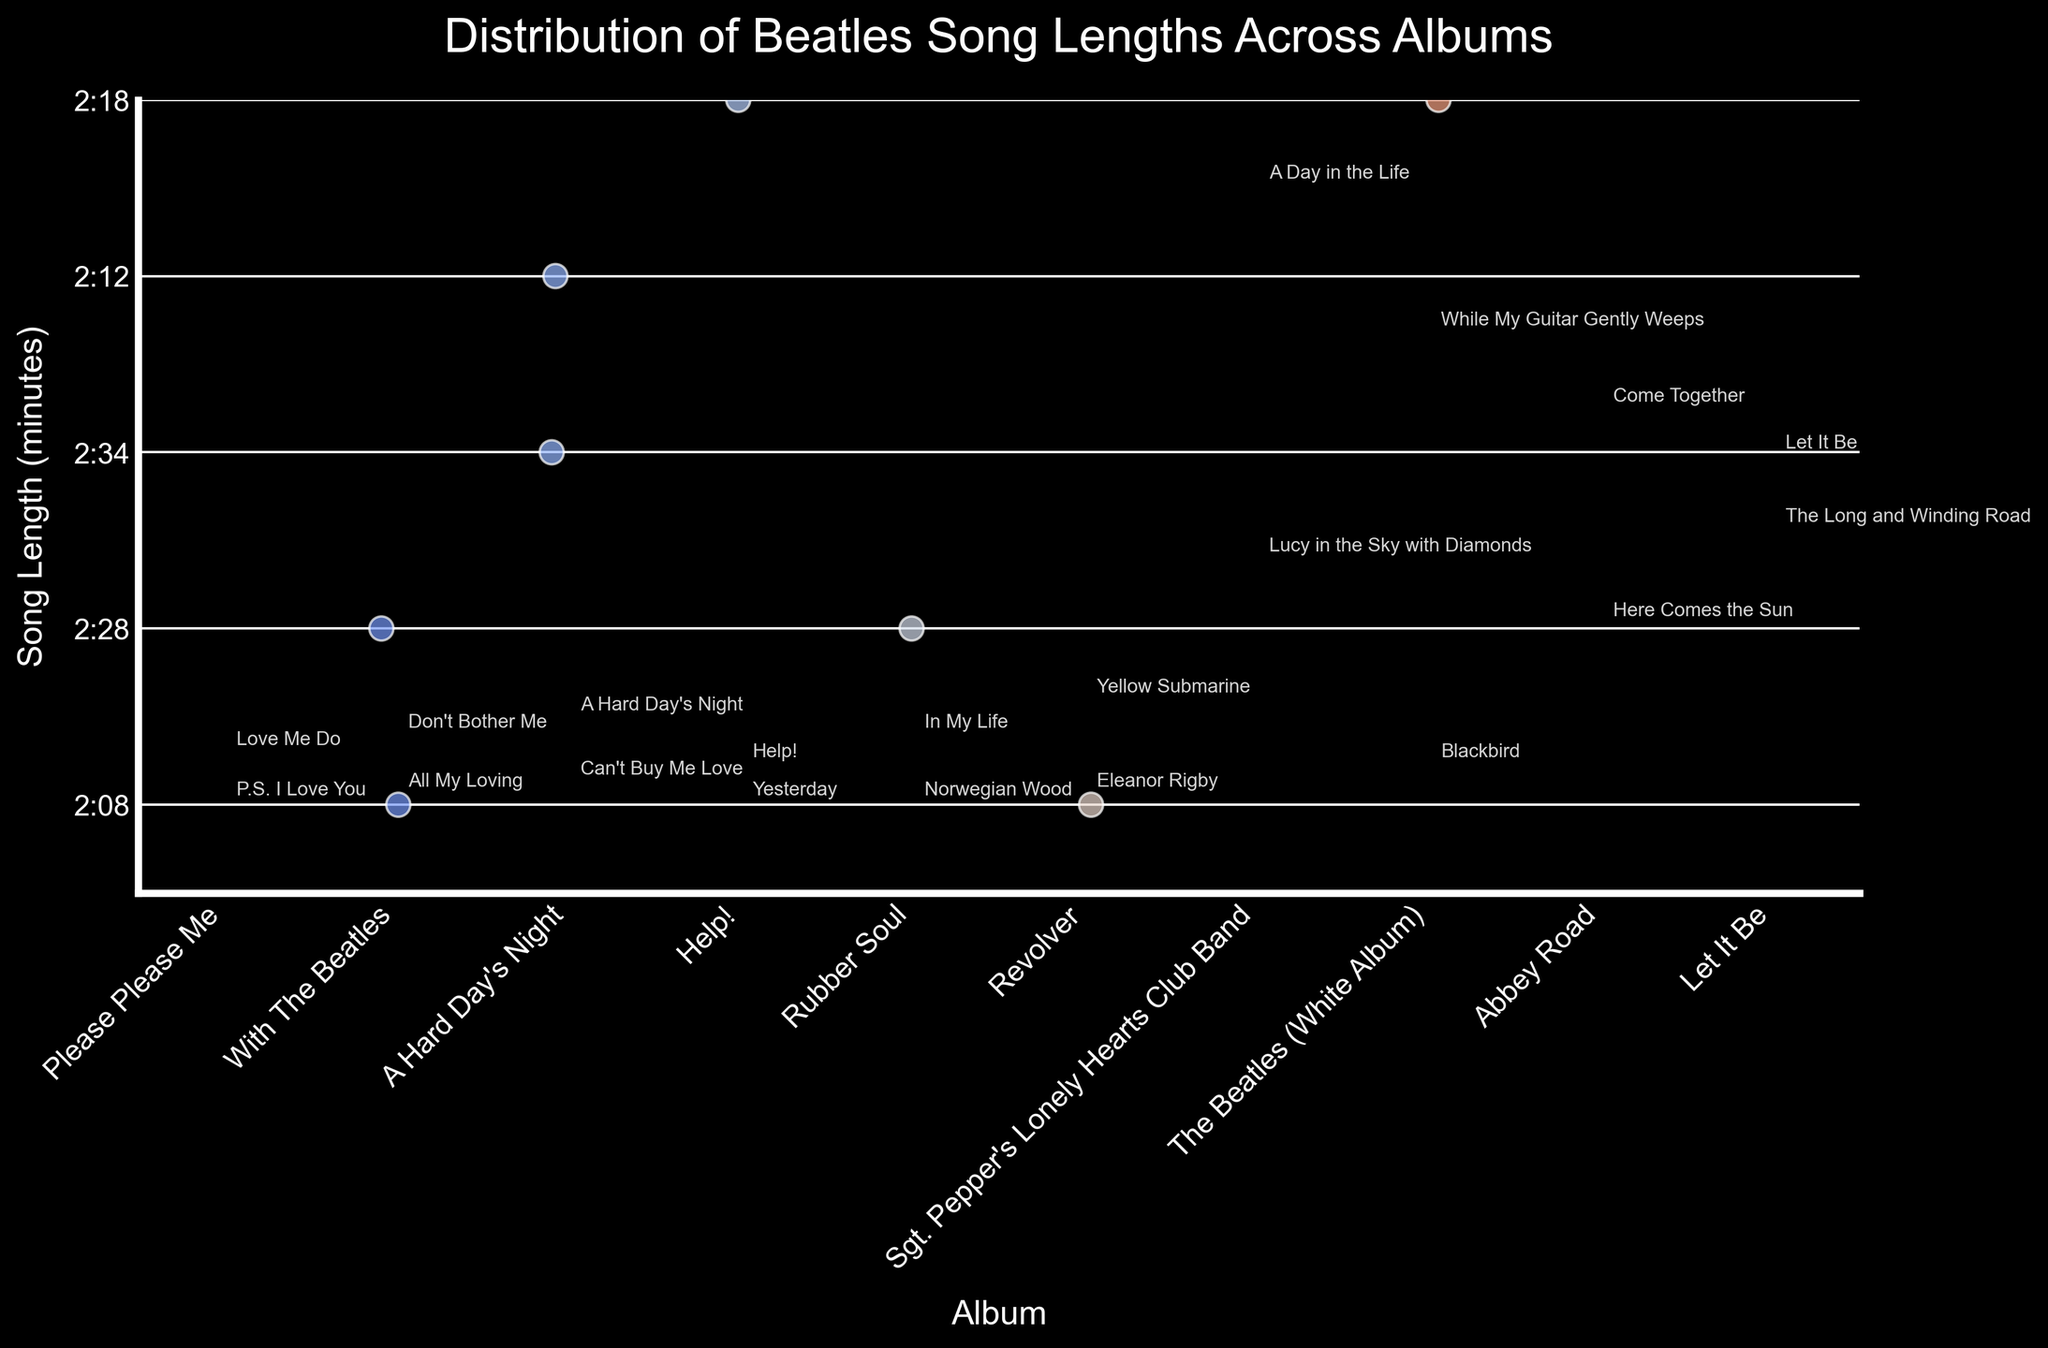what is the title of the figure? The title of the figure is usually found at the top, central part of the plot. It is often larger in font size compared to other text in the plot.
Answer: Distribution of Beatles Song Lengths Across Albums which album has the longest average song length? To find the album with the longest average song length, identify all song lengths per album and calculate the average for each. The album with the highest average is the answer.
Answer: The Beatles (White Album) what is the shortest song length on the album "Help!"? Locate the songs under the "Help!" album and check the length values of these songs. The shortest one will be the answer.
Answer: 2:05 which album contains the song with the longest length? Identify the album associated with the song of the longest length by evaluating all song lengths in the plot.
Answer: Sgt. Pepper's Lonely Hearts Club Band how many songs from the "Rubber Soul" album are included in the plot? Identify and count all the songs listed under the "Rubber Soul" album in the plot.
Answer: 2 which two albums have the shortest and longest songs respectively? Find the lengths of the shortest and longest songs in the plot and determine which albums they belong to.
Answer: Shortest: Please Please Me, Longest: Sgt. Pepper's Lonely Hearts Club Band compare the average song lengths between "A Hard Day's Night" and "Abbey Road" Calculate the average song length for each of the albums "A Hard Day's Night" and "Abbey Road", then compare the two averages.
Answer: Abbey Road has longer average song lengths than A Hard Day's Night do any albums have a song length exceeding 5 minutes? Analyze all song lengths and identify if any songs are greater than 5 minutes in duration. Check the album they belong to.
Answer: Yes, Sgt. Pepper's Lonely Hearts Club Band which album has the greatest range in song lengths? For each album, find the difference between the maximum and minimum song lengths, and identify the album with the highest difference.
Answer: The Beatles (White Album) how does the number of songs on "With The Beatles" compare to "Revolver"? Count the number of songs on each of the albums "With The Beatles" and "Revolver" in the plot and make a comparison.
Answer: They have an equal number of songs 